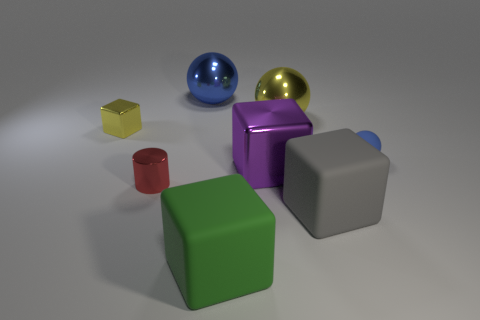Do the metallic sphere left of the green matte cube and the red thing have the same size?
Keep it short and to the point. No. How many spheres are small blue rubber things or large gray objects?
Your answer should be compact. 1. What material is the big ball left of the purple metallic cube?
Provide a short and direct response. Metal. Are there fewer large blue objects than cyan blocks?
Provide a succinct answer. No. How big is the cube that is both behind the small red metal cylinder and right of the small red metal object?
Your answer should be very brief. Large. There is a thing behind the large shiny sphere on the right side of the big matte object on the left side of the gray thing; what is its size?
Give a very brief answer. Large. How many other things are the same color as the rubber ball?
Your response must be concise. 1. There is a cube that is left of the red shiny cylinder; is it the same color as the large metallic cube?
Offer a terse response. No. How many objects are small blue matte balls or tiny brown matte balls?
Your response must be concise. 1. There is a big matte cube that is left of the big gray cube; what color is it?
Provide a short and direct response. Green. 